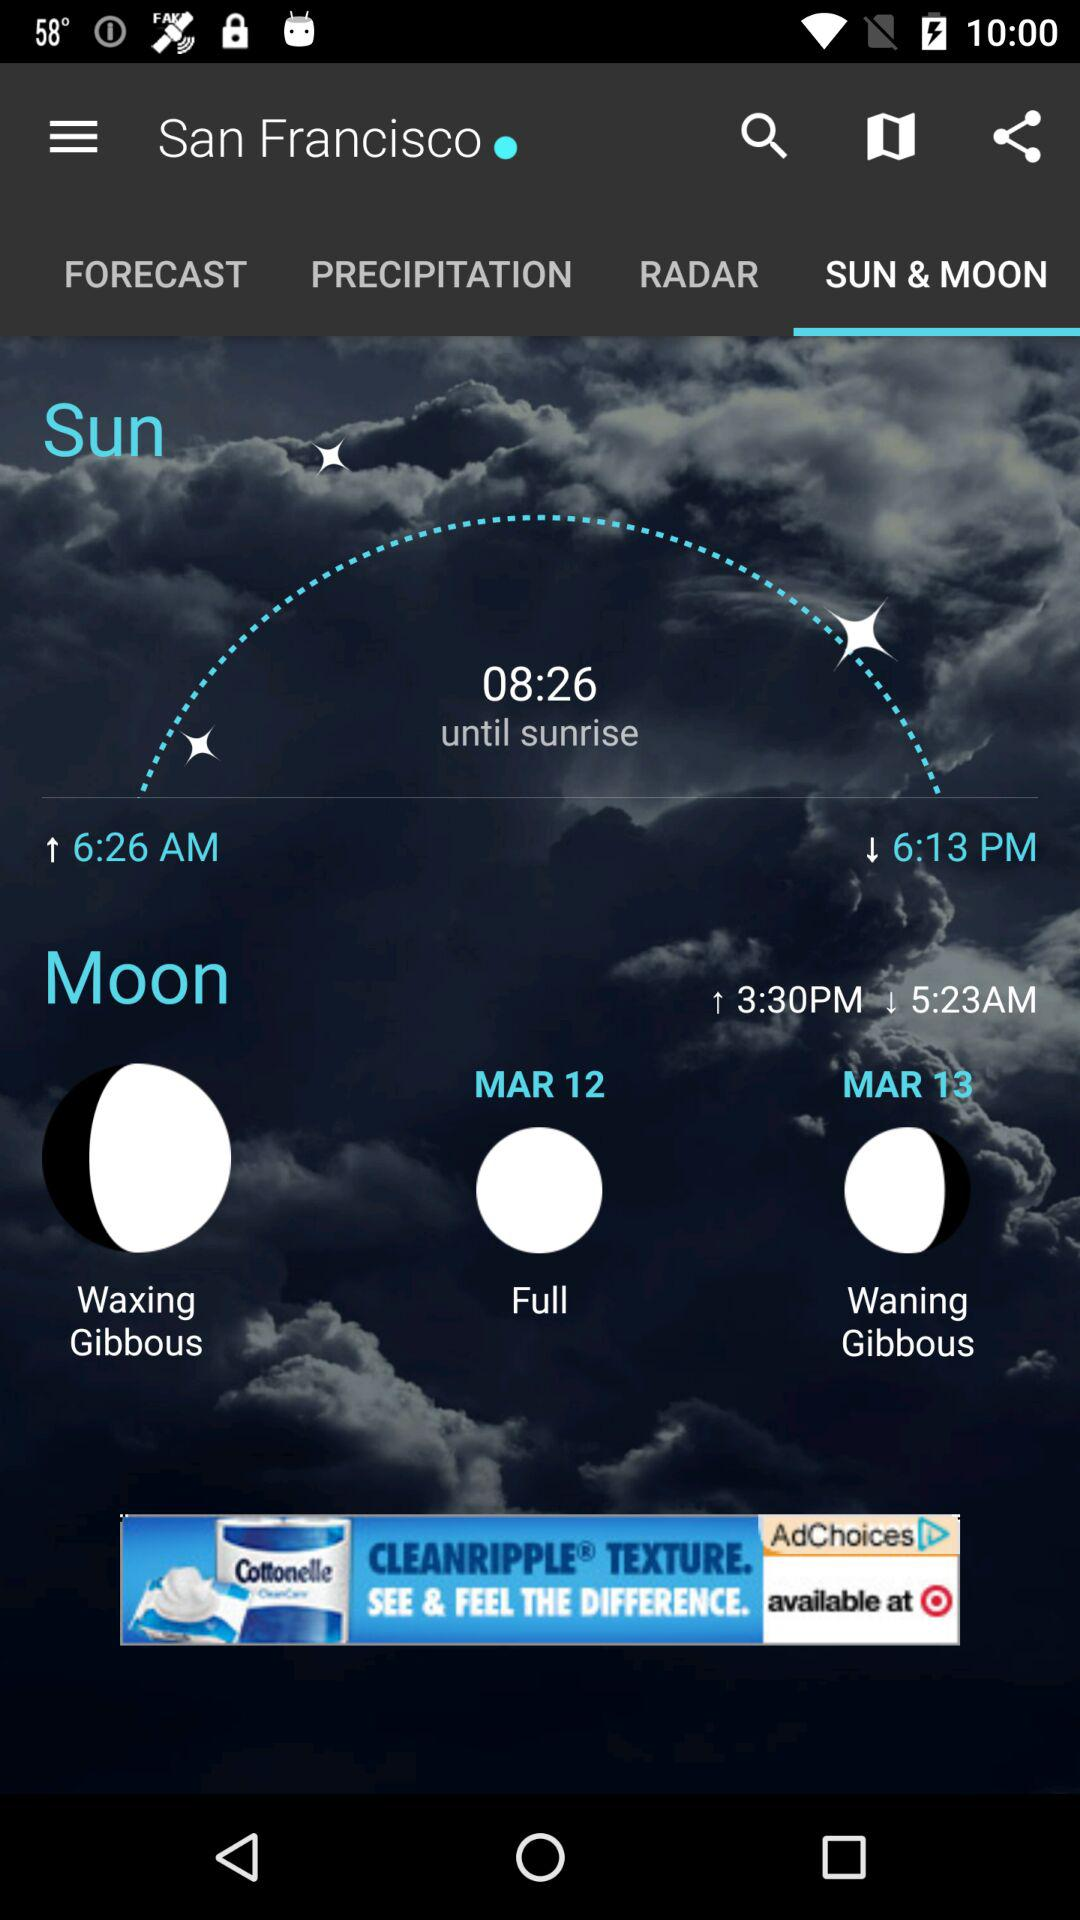What is the time of the sunrise? The time of the sunrise is 6:26 a.m. 